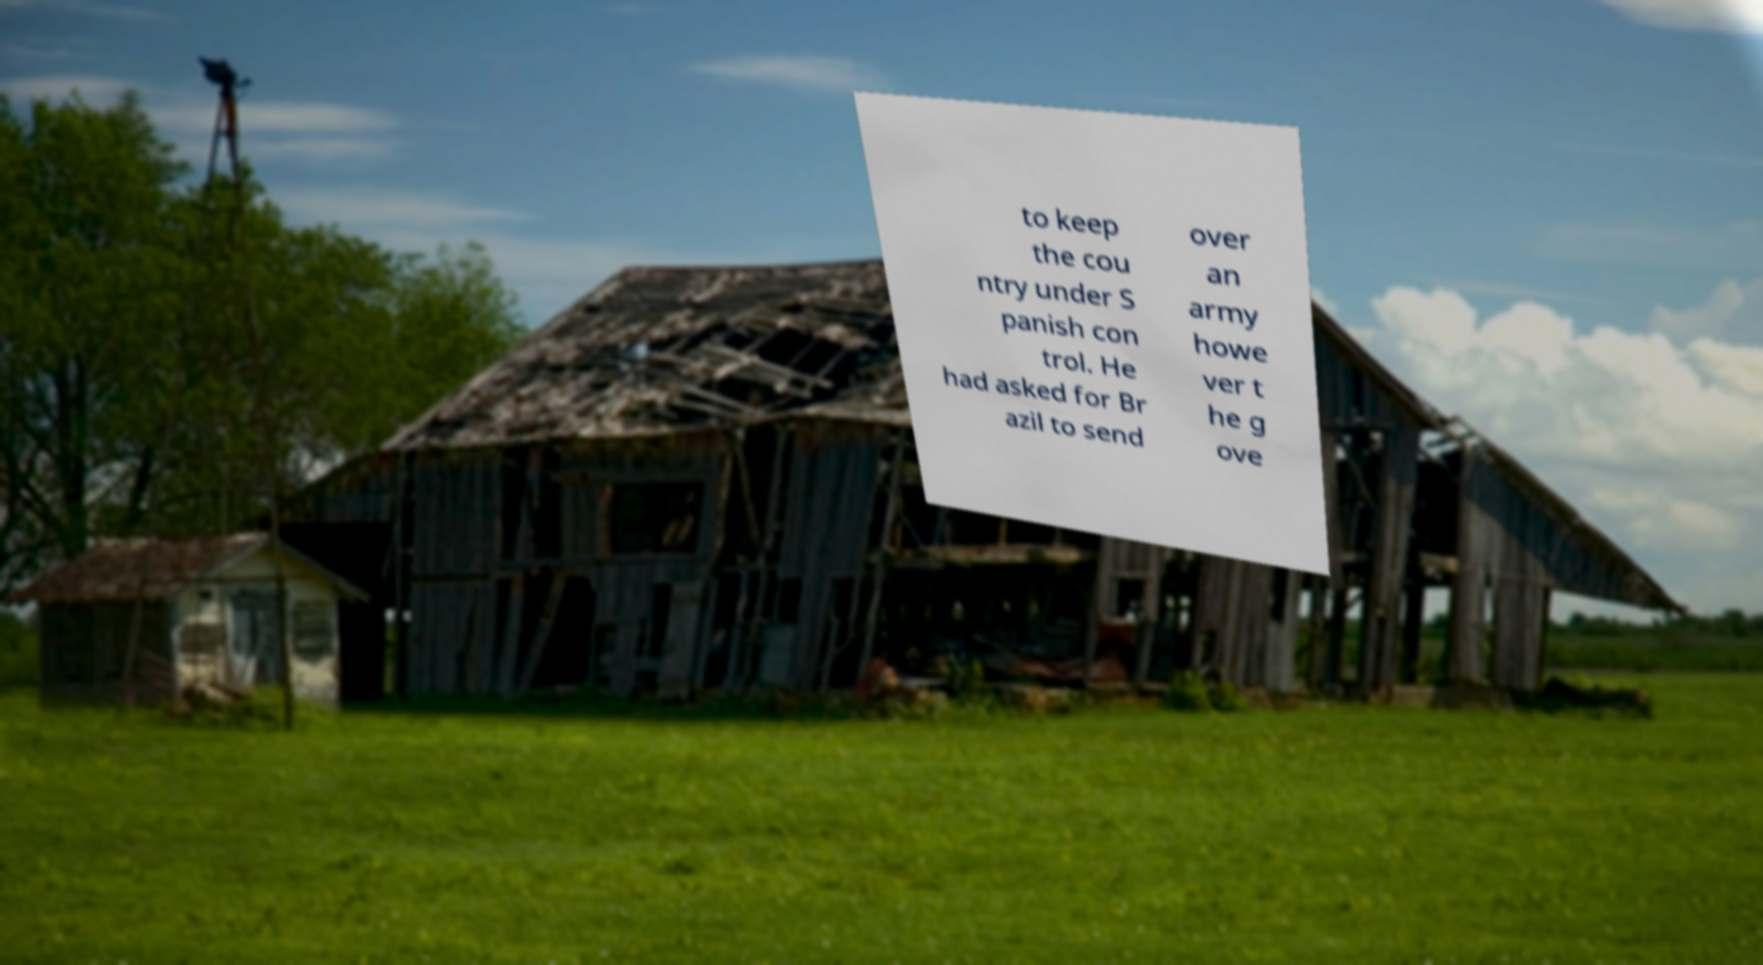Could you extract and type out the text from this image? to keep the cou ntry under S panish con trol. He had asked for Br azil to send over an army howe ver t he g ove 